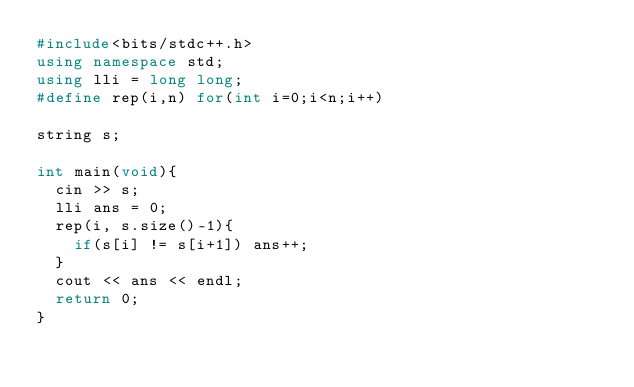<code> <loc_0><loc_0><loc_500><loc_500><_C++_>#include<bits/stdc++.h>
using namespace std;
using lli = long long;
#define rep(i,n) for(int i=0;i<n;i++)

string s;

int main(void){
	cin >> s;
	lli ans = 0;
	rep(i, s.size()-1){
		if(s[i] != s[i+1]) ans++;
	}
	cout << ans << endl;
	return 0;
}
</code> 